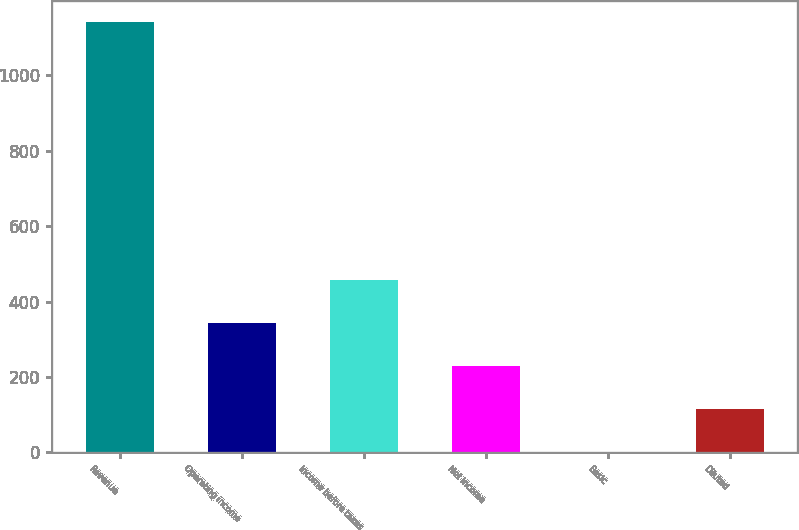Convert chart to OTSL. <chart><loc_0><loc_0><loc_500><loc_500><bar_chart><fcel>Revenue<fcel>Operating income<fcel>Income before taxes<fcel>Net income<fcel>Basic<fcel>Diluted<nl><fcel>1140.3<fcel>342.57<fcel>456.53<fcel>228.61<fcel>0.69<fcel>114.65<nl></chart> 